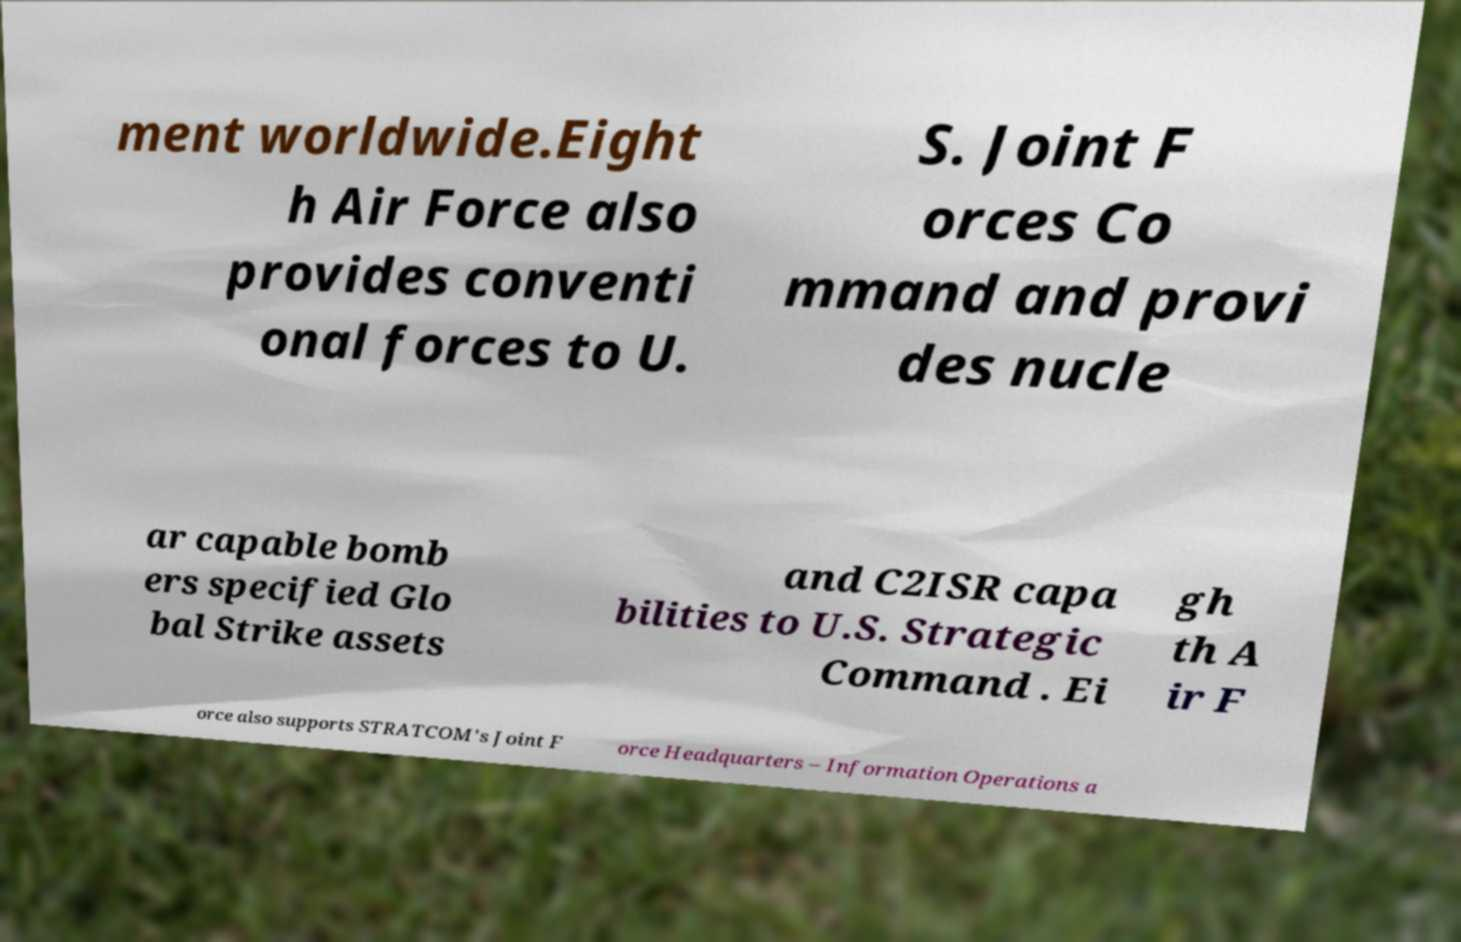Please identify and transcribe the text found in this image. ment worldwide.Eight h Air Force also provides conventi onal forces to U. S. Joint F orces Co mmand and provi des nucle ar capable bomb ers specified Glo bal Strike assets and C2ISR capa bilities to U.S. Strategic Command . Ei gh th A ir F orce also supports STRATCOM's Joint F orce Headquarters – Information Operations a 